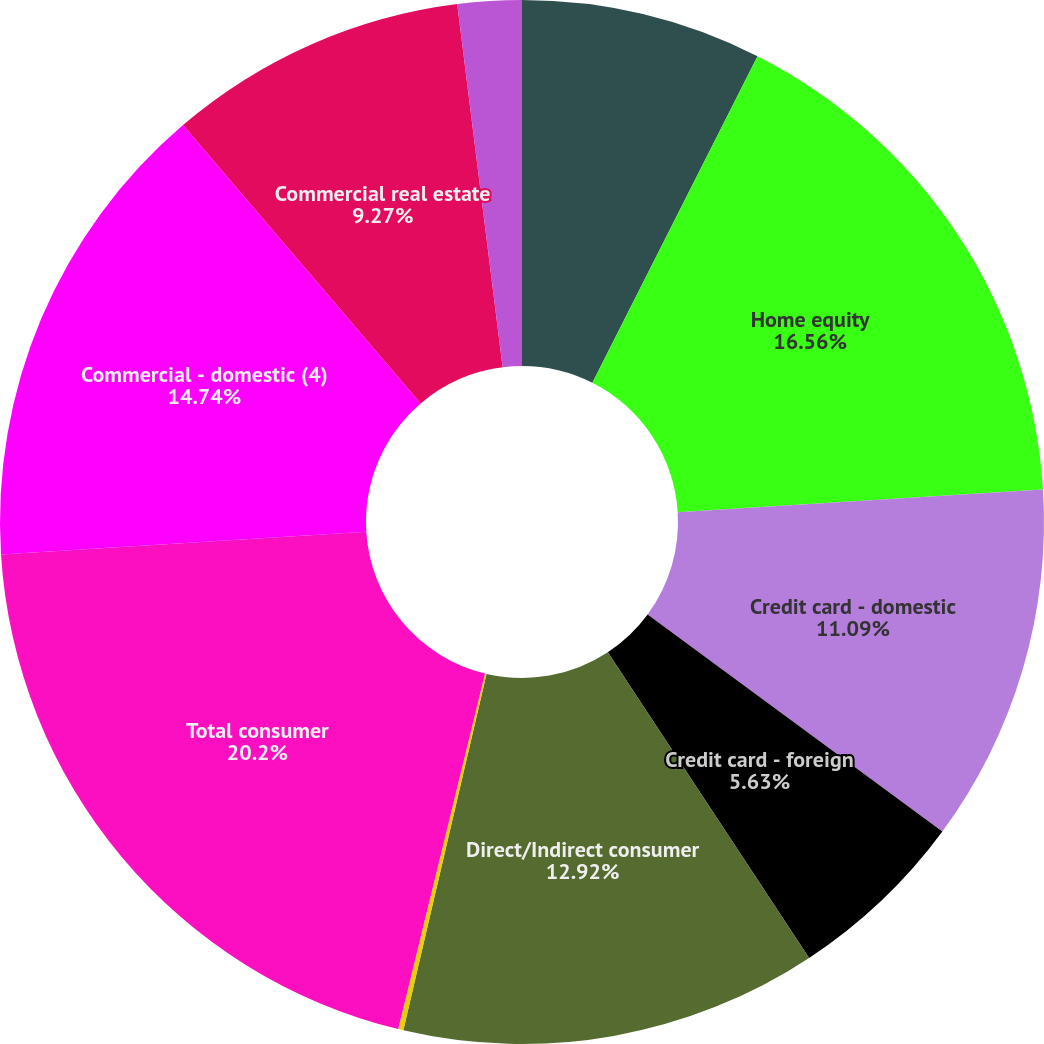Convert chart to OTSL. <chart><loc_0><loc_0><loc_500><loc_500><pie_chart><fcel>Residential mortgage (3)<fcel>Home equity<fcel>Credit card - domestic<fcel>Credit card - foreign<fcel>Direct/Indirect consumer<fcel>Other consumer<fcel>Total consumer<fcel>Commercial - domestic (4)<fcel>Commercial real estate<fcel>Commercial lease financing<nl><fcel>7.45%<fcel>16.56%<fcel>11.09%<fcel>5.63%<fcel>12.92%<fcel>0.16%<fcel>20.2%<fcel>14.74%<fcel>9.27%<fcel>1.98%<nl></chart> 